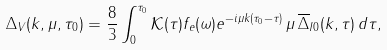Convert formula to latex. <formula><loc_0><loc_0><loc_500><loc_500>\Delta _ { V } ( k , \mu , \tau _ { 0 } ) = \frac { 8 } { 3 } \int _ { 0 } ^ { \tau _ { 0 } } { \mathcal { K } } ( \tau ) f _ { e } ( \omega ) e ^ { - i \mu k ( \tau _ { 0 } - \tau ) } \, \mu \, \overline { \Delta } _ { I 0 } ( k , \tau ) \, d \tau ,</formula> 